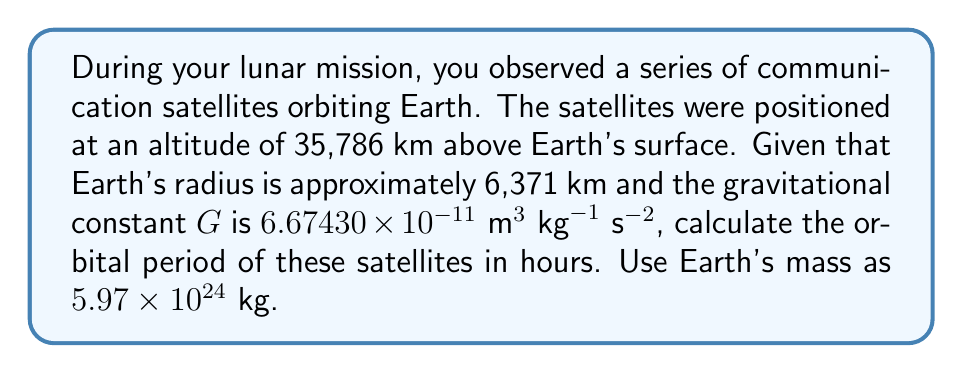Help me with this question. To determine the orbital period of the satellites, we'll use Kepler's Third Law of Planetary Motion, which relates the orbital period to the semi-major axis of the orbit.

1) First, calculate the semi-major axis (a):
   $a = \text{Earth's radius} + \text{Satellite altitude}$
   $a = 6,371 \text{ km} + 35,786 \text{ km} = 42,157 \text{ km} = 42,157,000 \text{ m}$

2) Kepler's Third Law in terms of the gravitational constant is:

   $$T^2 = \frac{4\pi^2a^3}{GM}$$

   Where:
   $T$ is the orbital period
   $a$ is the semi-major axis
   $G$ is the gravitational constant
   $M$ is the mass of Earth

3) Substituting the values:

   $$T^2 = \frac{4\pi^2(42,157,000 \text{ m})^3}{(6.67430 \times 10^{-11} \text{ m}^3 \text{ kg}^{-1} \text{ s}^{-2})(5.97 \times 10^{24} \text{ kg})}$$

4) Solve for $T$:

   $$T = \sqrt{\frac{4\pi^2(42,157,000 \text{ m})^3}{(6.67430 \times 10^{-11} \text{ m}^3 \text{ kg}^{-1} \text{ s}^{-2})(5.97 \times 10^{24} \text{ kg})}}$$

5) Calculate:
   $T \approx 86,164 \text{ seconds}$

6) Convert to hours:
   $86,164 \text{ seconds} \div 3600 \text{ seconds/hour} \approx 23.93 \text{ hours}$
Answer: 23.93 hours 